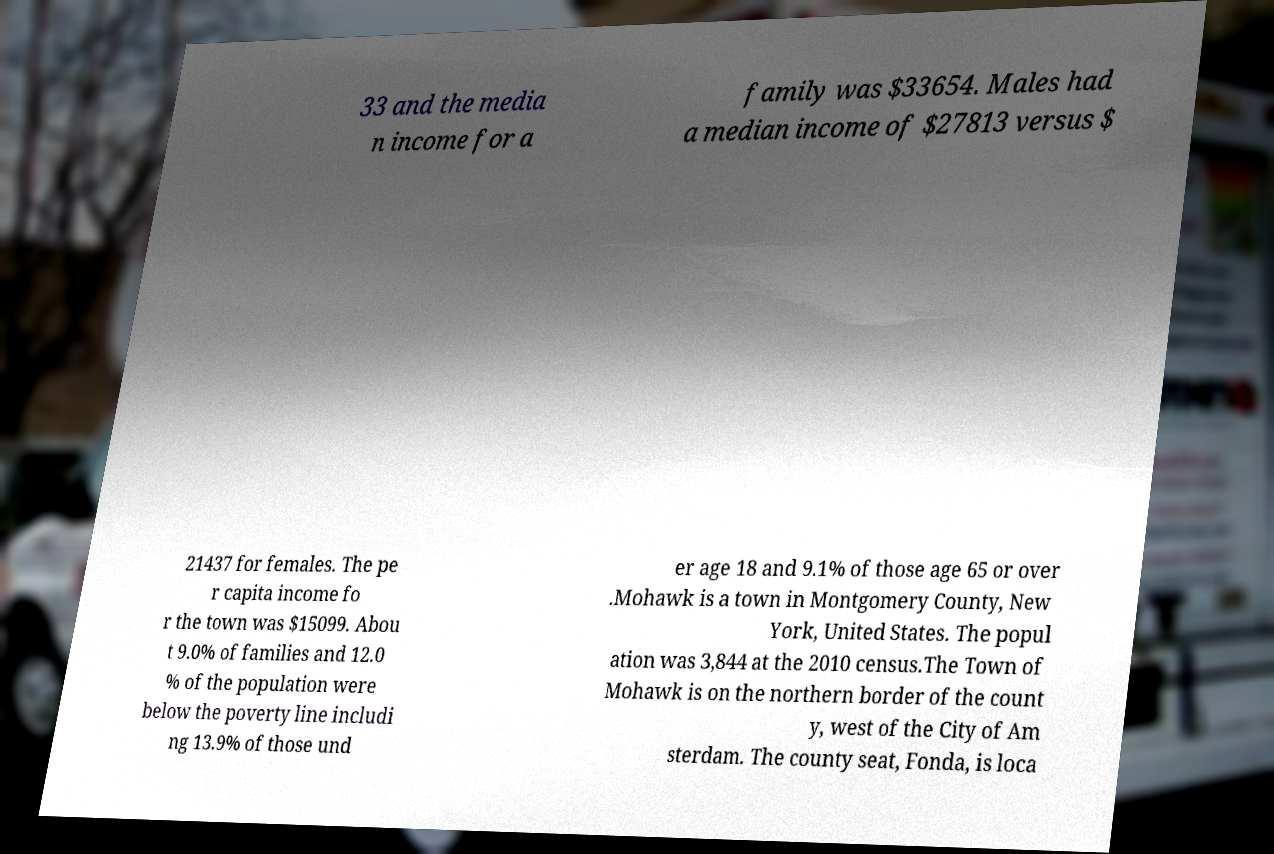Could you assist in decoding the text presented in this image and type it out clearly? 33 and the media n income for a family was $33654. Males had a median income of $27813 versus $ 21437 for females. The pe r capita income fo r the town was $15099. Abou t 9.0% of families and 12.0 % of the population were below the poverty line includi ng 13.9% of those und er age 18 and 9.1% of those age 65 or over .Mohawk is a town in Montgomery County, New York, United States. The popul ation was 3,844 at the 2010 census.The Town of Mohawk is on the northern border of the count y, west of the City of Am sterdam. The county seat, Fonda, is loca 